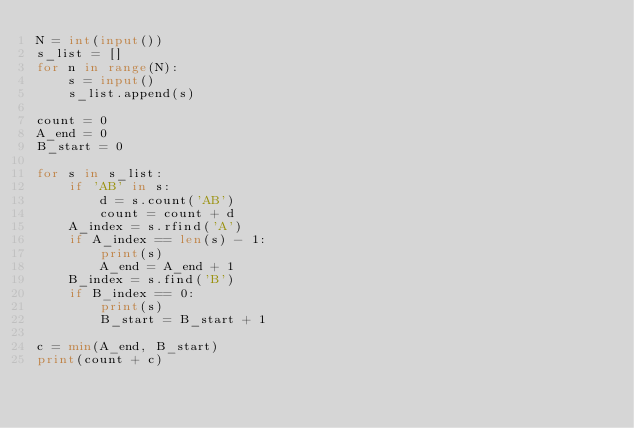<code> <loc_0><loc_0><loc_500><loc_500><_Python_>N = int(input())
s_list = []
for n in range(N):
    s = input()
    s_list.append(s)

count = 0
A_end = 0
B_start = 0

for s in s_list:
    if 'AB' in s:
        d = s.count('AB')
        count = count + d
    A_index = s.rfind('A')
    if A_index == len(s) - 1:
        print(s)
        A_end = A_end + 1
    B_index = s.find('B')
    if B_index == 0:
        print(s)
        B_start = B_start + 1

c = min(A_end, B_start)
print(count + c)
</code> 